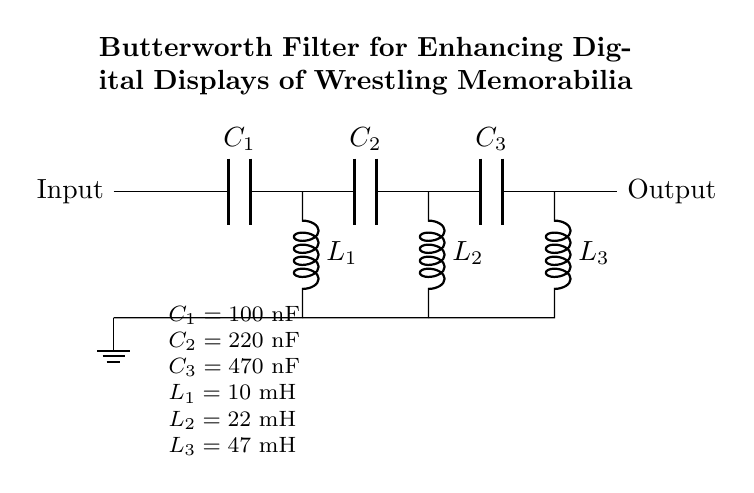What type of filter is shown in the circuit? The circuit diagram represents a Butterworth filter, which is characterized by its maximally flat frequency response in the passband. The title of the diagram explicitly states that it is a Butterworth filter.
Answer: Butterworth filter How many capacitors are in this circuit? There are three capacitors in the circuit, labeled C1, C2, and C3. Each is indicated in the circuit diagram showing the relevant positions and values.
Answer: Three What is the value of L3? The value of L3 is 47 mH, which is specified in the component values listed beneath the circuit diagram.
Answer: 47 mH What is the function of the capacitors in this filter? The capacitors in a Butterworth filter serve to store energy and help create the desired frequency response by allowing certain frequencies to pass while attenuating others. Capacitors work in conjunction with inductors to shape the filter characteristics.
Answer: Frequency response shaping What happens if you increase the capacitance of C1? Increasing the capacitance of C1 will lower the cutoff frequency of the filter, allowing more of the lower-frequency signals to pass through. This is because a larger capacitor in parallel with the impedance reduces the effective impedance at lower frequencies.
Answer: Lowers the cutoff frequency Which inductor has the highest inductance value? The inductor with the highest inductance value is L3, which has a value of 47 mH as indicated in the circuit.
Answer: L3 